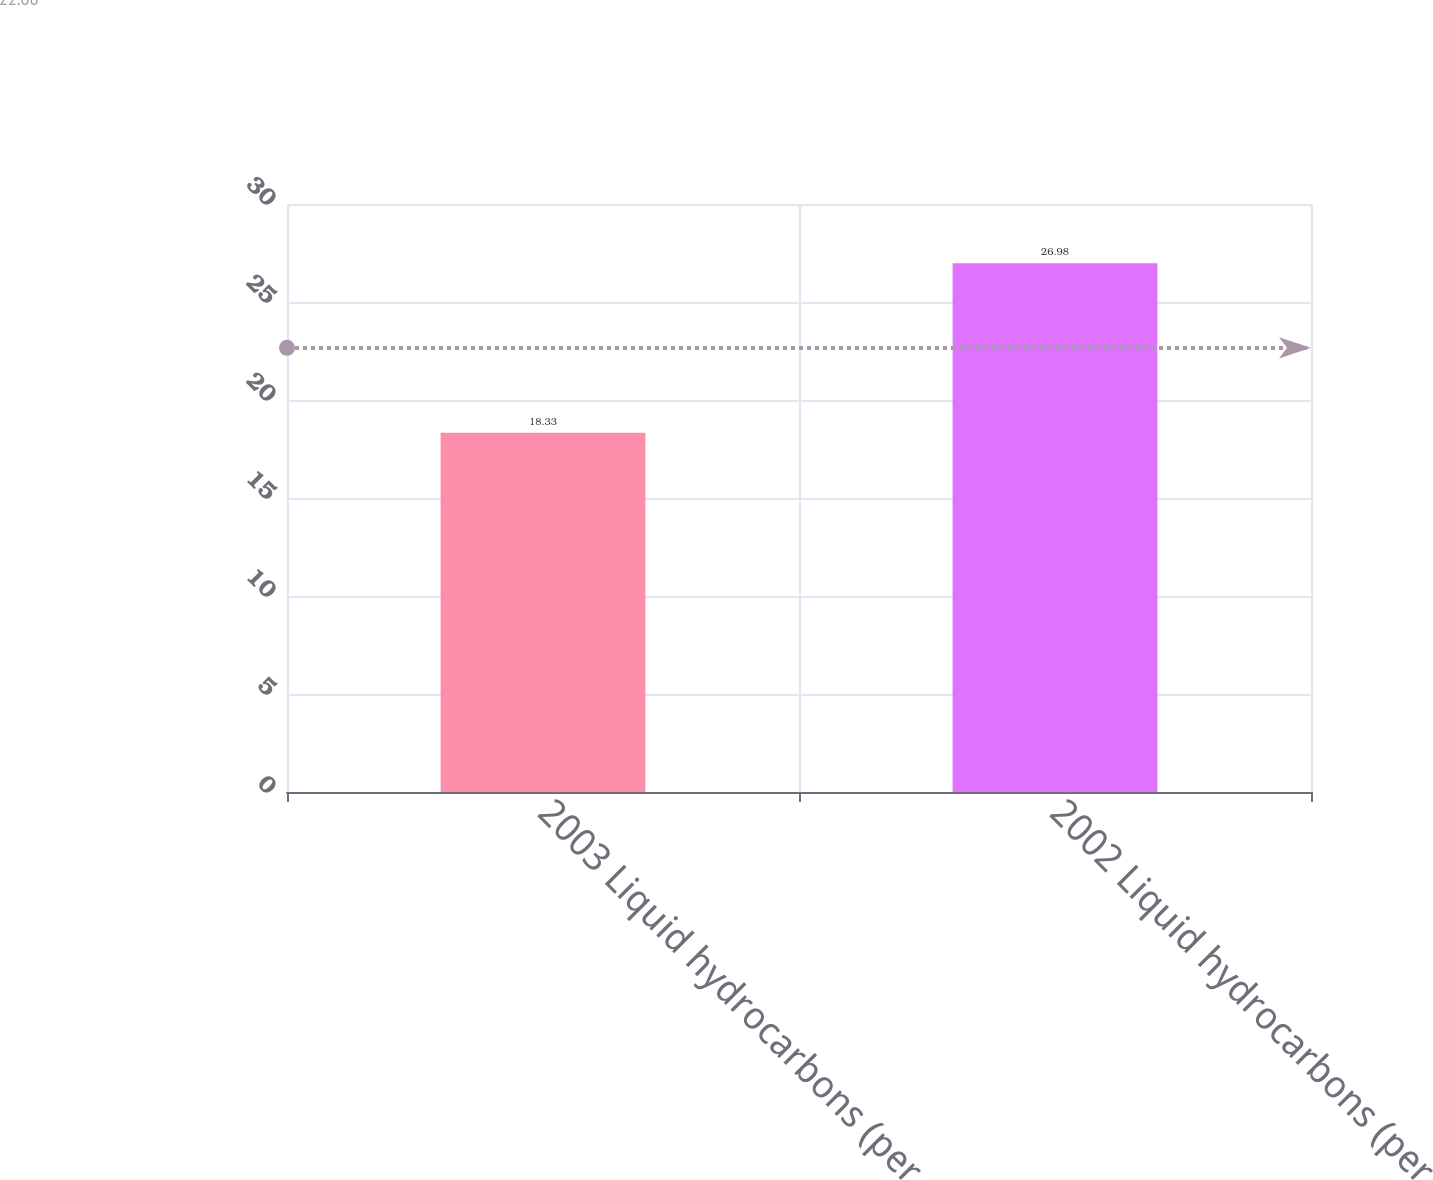Convert chart. <chart><loc_0><loc_0><loc_500><loc_500><bar_chart><fcel>2003 Liquid hydrocarbons (per<fcel>2002 Liquid hydrocarbons (per<nl><fcel>18.33<fcel>26.98<nl></chart> 